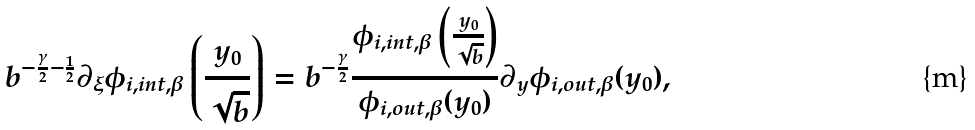<formula> <loc_0><loc_0><loc_500><loc_500>b ^ { - \frac { \gamma } { 2 } - \frac { 1 } { 2 } } \partial _ { \xi } \phi _ { i , i n t , \beta } \left ( \frac { y _ { 0 } } { \sqrt { b } } \right ) = b ^ { - \frac { \gamma } { 2 } } \frac { \phi _ { i , i n t , \beta } \left ( \frac { y _ { 0 } } { \sqrt { b } } \right ) } { \phi _ { i , o u t , \beta } ( y _ { 0 } ) } \partial _ { y } \phi _ { i , o u t , \beta } ( y _ { 0 } ) ,</formula> 